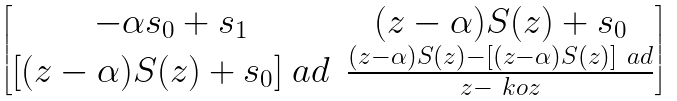<formula> <loc_0><loc_0><loc_500><loc_500>\begin{bmatrix} - \alpha s _ { 0 } + s _ { 1 } & ( z - \alpha ) S ( z ) + s _ { 0 } \\ [ ( z - \alpha ) S ( z ) + s _ { 0 } ] ^ { \ } a d & \frac { ( z - \alpha ) S ( z ) - [ ( z - \alpha ) S ( z ) ] ^ { \ } a d } { z - \ k o { z } } \end{bmatrix}</formula> 